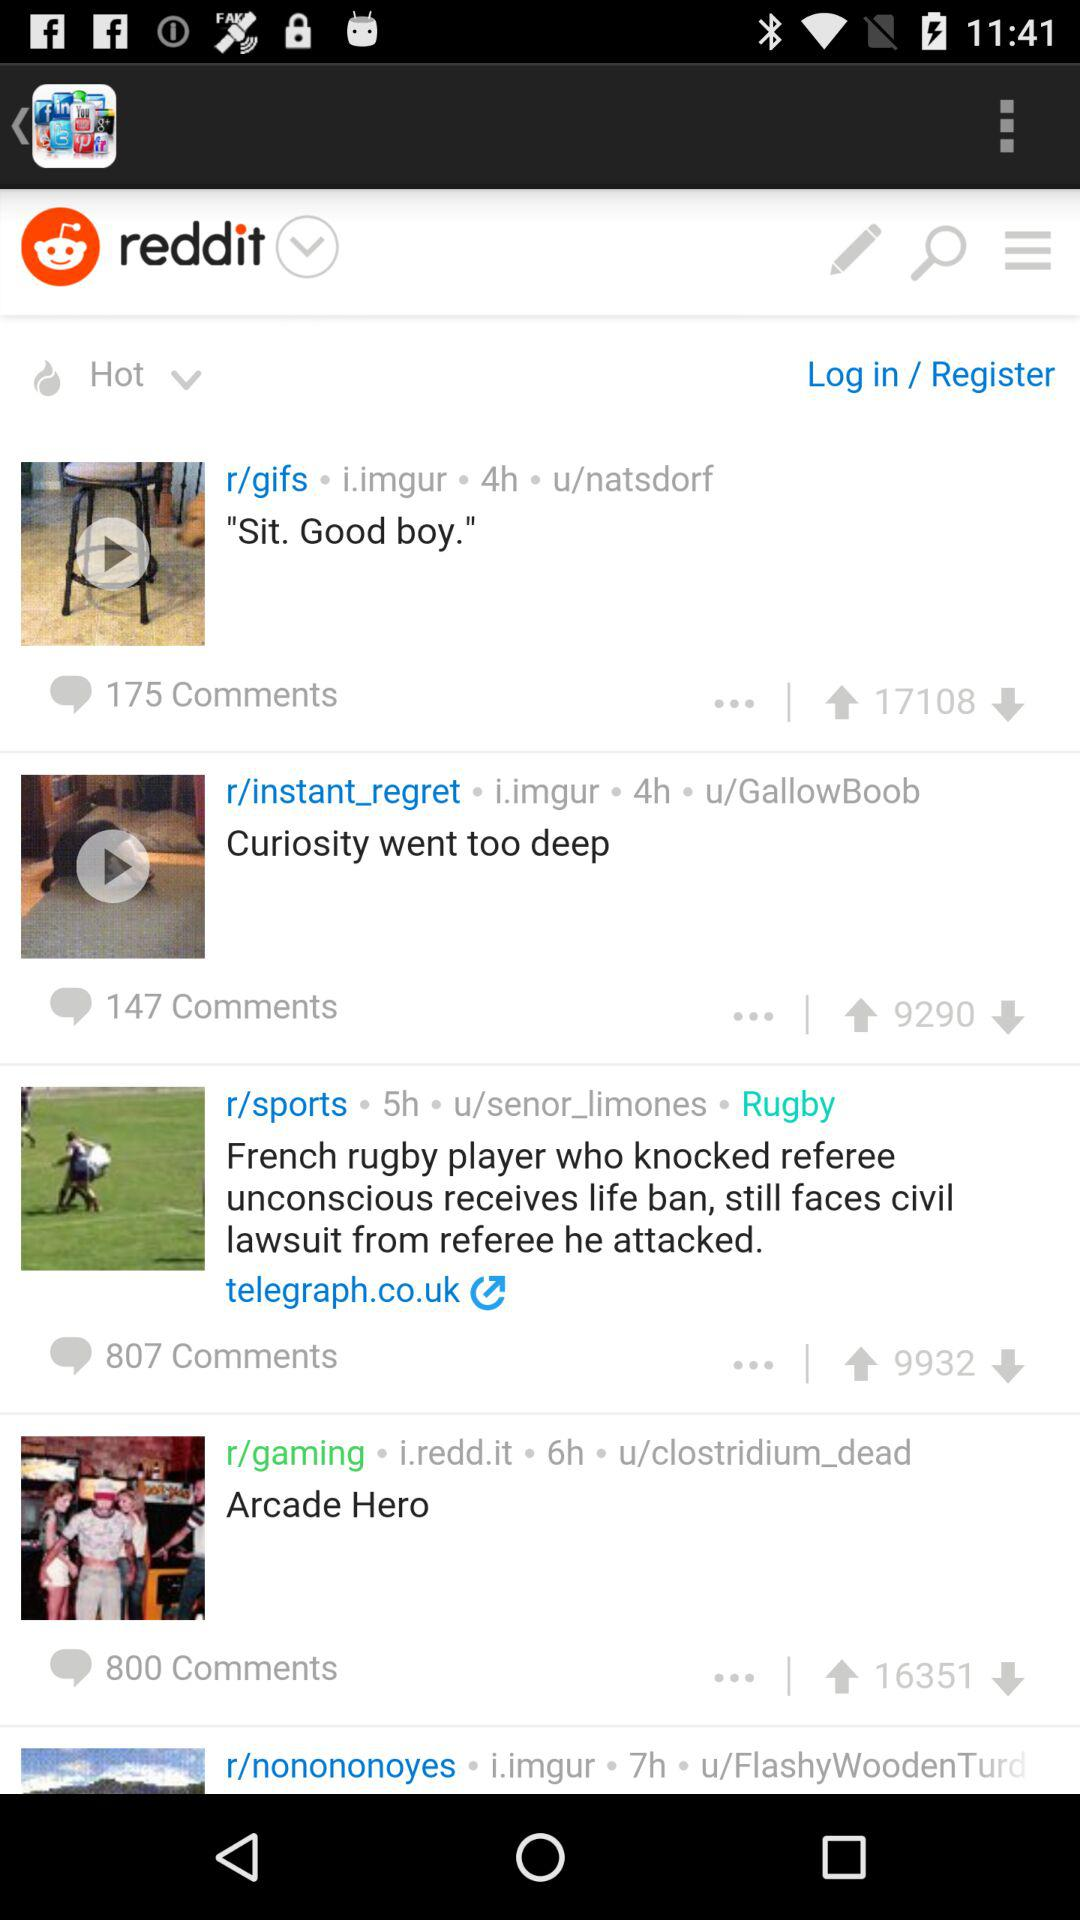How many upvotes are there for "Curiosity went too deep"? There are 9,290 upvotes. 